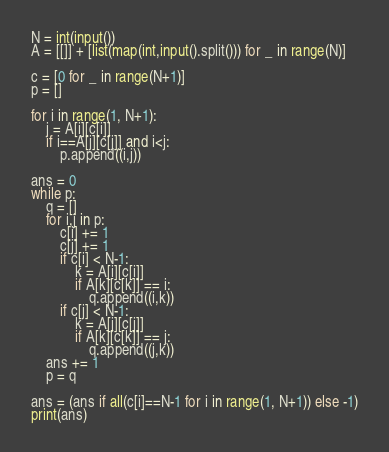<code> <loc_0><loc_0><loc_500><loc_500><_Python_>N = int(input())
A = [[]] + [list(map(int,input().split())) for _ in range(N)]

c = [0 for _ in range(N+1)]
p = []

for i in range(1, N+1):
    j = A[i][c[i]]
    if i==A[j][c[j]] and i<j:
        p.append((i,j))

ans = 0
while p:
    q = []
    for i,j in p:
        c[i] += 1
        c[j] += 1
        if c[i] < N-1:
            k = A[i][c[i]]
            if A[k][c[k]] == i:
                q.append((i,k))
        if c[j] < N-1:
            k = A[j][c[j]]
            if A[k][c[k]] == j:
                q.append((j,k))
    ans += 1
    p = q

ans = (ans if all(c[i]==N-1 for i in range(1, N+1)) else -1)
print(ans)</code> 